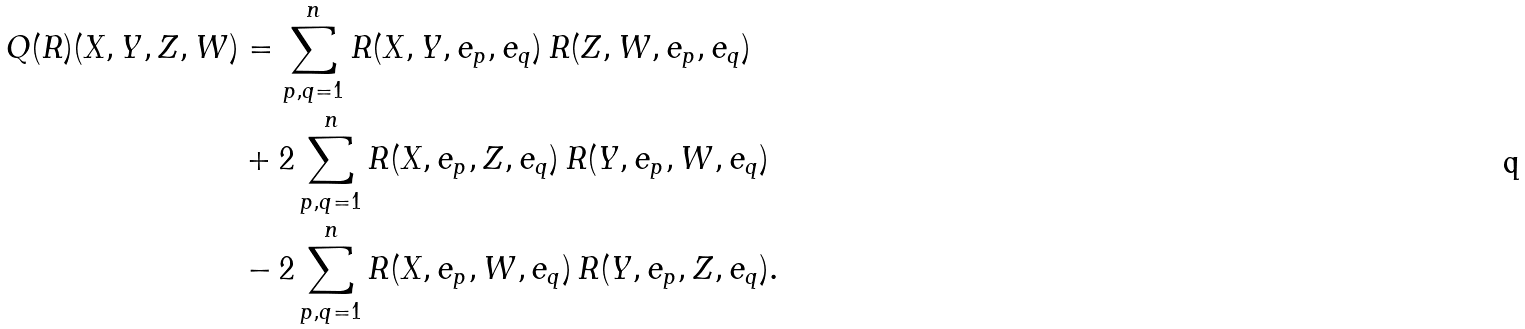<formula> <loc_0><loc_0><loc_500><loc_500>Q ( R ) ( X , Y , Z , W ) & = \sum _ { p , q = 1 } ^ { n } R ( X , Y , e _ { p } , e _ { q } ) \, R ( Z , W , e _ { p } , e _ { q } ) \\ & + 2 \sum _ { p , q = 1 } ^ { n } R ( X , e _ { p } , Z , e _ { q } ) \, R ( Y , e _ { p } , W , e _ { q } ) \\ & - 2 \sum _ { p , q = 1 } ^ { n } R ( X , e _ { p } , W , e _ { q } ) \, R ( Y , e _ { p } , Z , e _ { q } ) .</formula> 